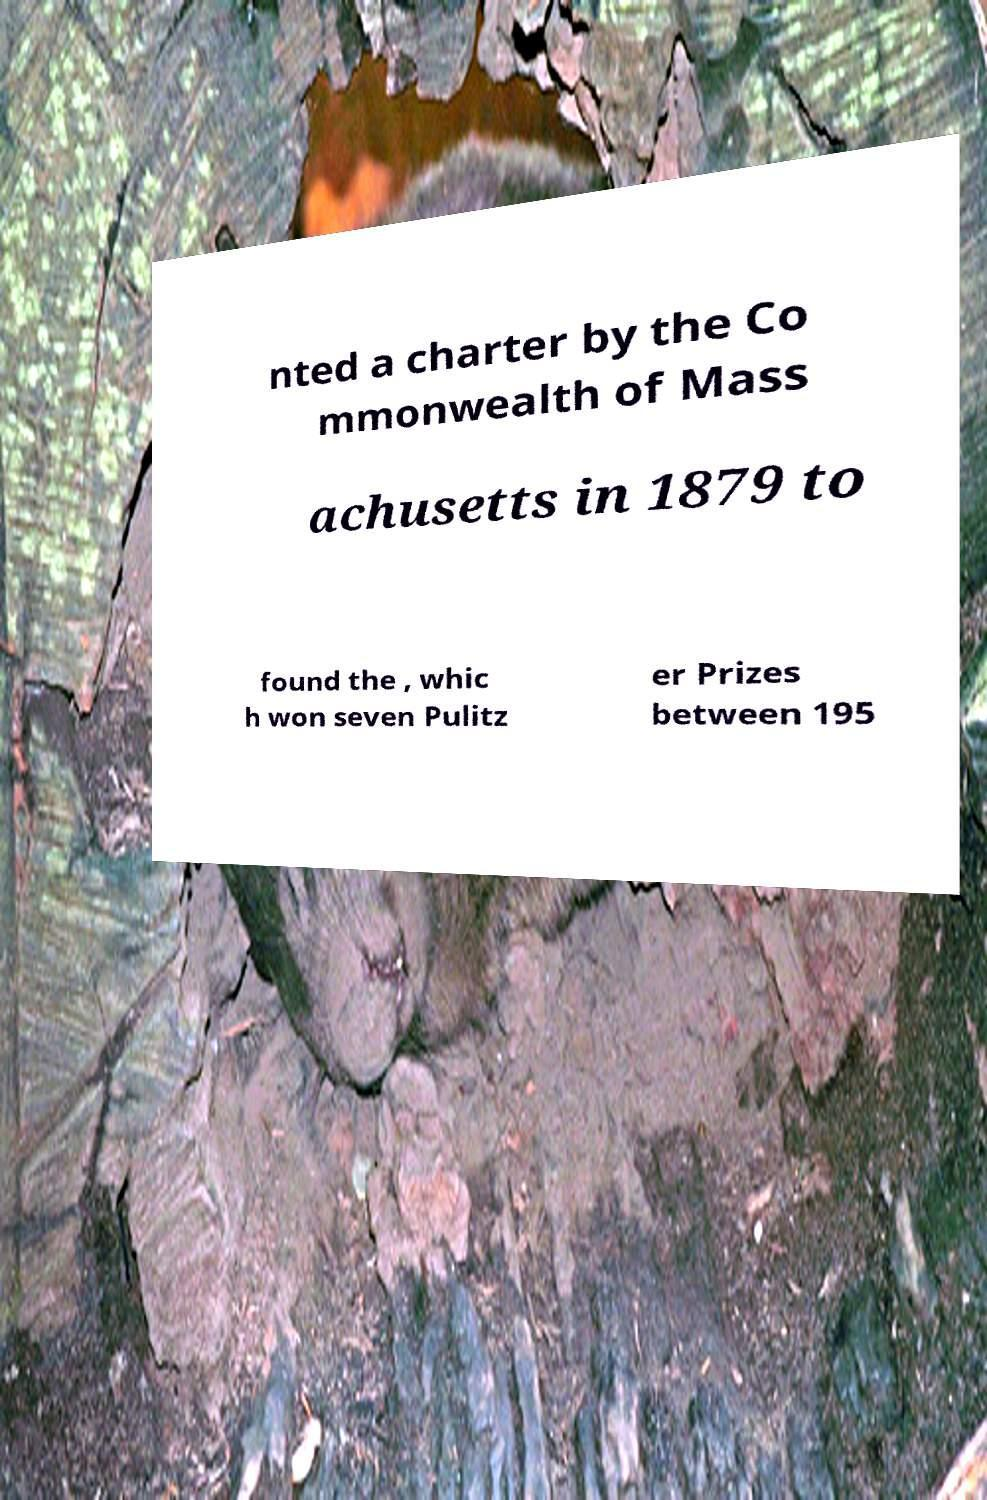Can you accurately transcribe the text from the provided image for me? nted a charter by the Co mmonwealth of Mass achusetts in 1879 to found the , whic h won seven Pulitz er Prizes between 195 